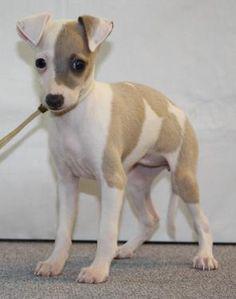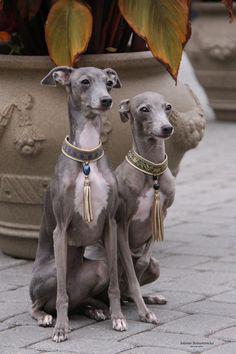The first image is the image on the left, the second image is the image on the right. Examine the images to the left and right. Is the description "The right image contains exactly two dogs seated next to each other looking towards the right." accurate? Answer yes or no. Yes. The first image is the image on the left, the second image is the image on the right. Assess this claim about the two images: "An image contains a pair of similarly-posed dogs wearing similar items around their necks.". Correct or not? Answer yes or no. Yes. 